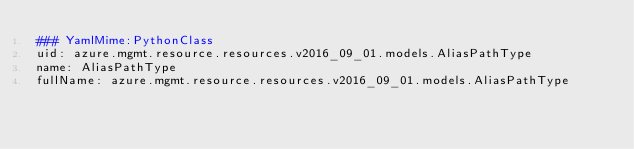Convert code to text. <code><loc_0><loc_0><loc_500><loc_500><_YAML_>### YamlMime:PythonClass
uid: azure.mgmt.resource.resources.v2016_09_01.models.AliasPathType
name: AliasPathType
fullName: azure.mgmt.resource.resources.v2016_09_01.models.AliasPathType</code> 